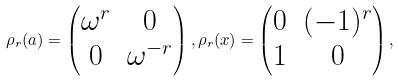<formula> <loc_0><loc_0><loc_500><loc_500>\rho _ { r } ( a ) = \begin{pmatrix} \omega ^ { r } & 0 \\ 0 & \omega ^ { - r } \end{pmatrix} , \rho _ { r } ( x ) = \begin{pmatrix} 0 & ( - 1 ) ^ { r } \\ 1 & 0 \end{pmatrix} ,</formula> 